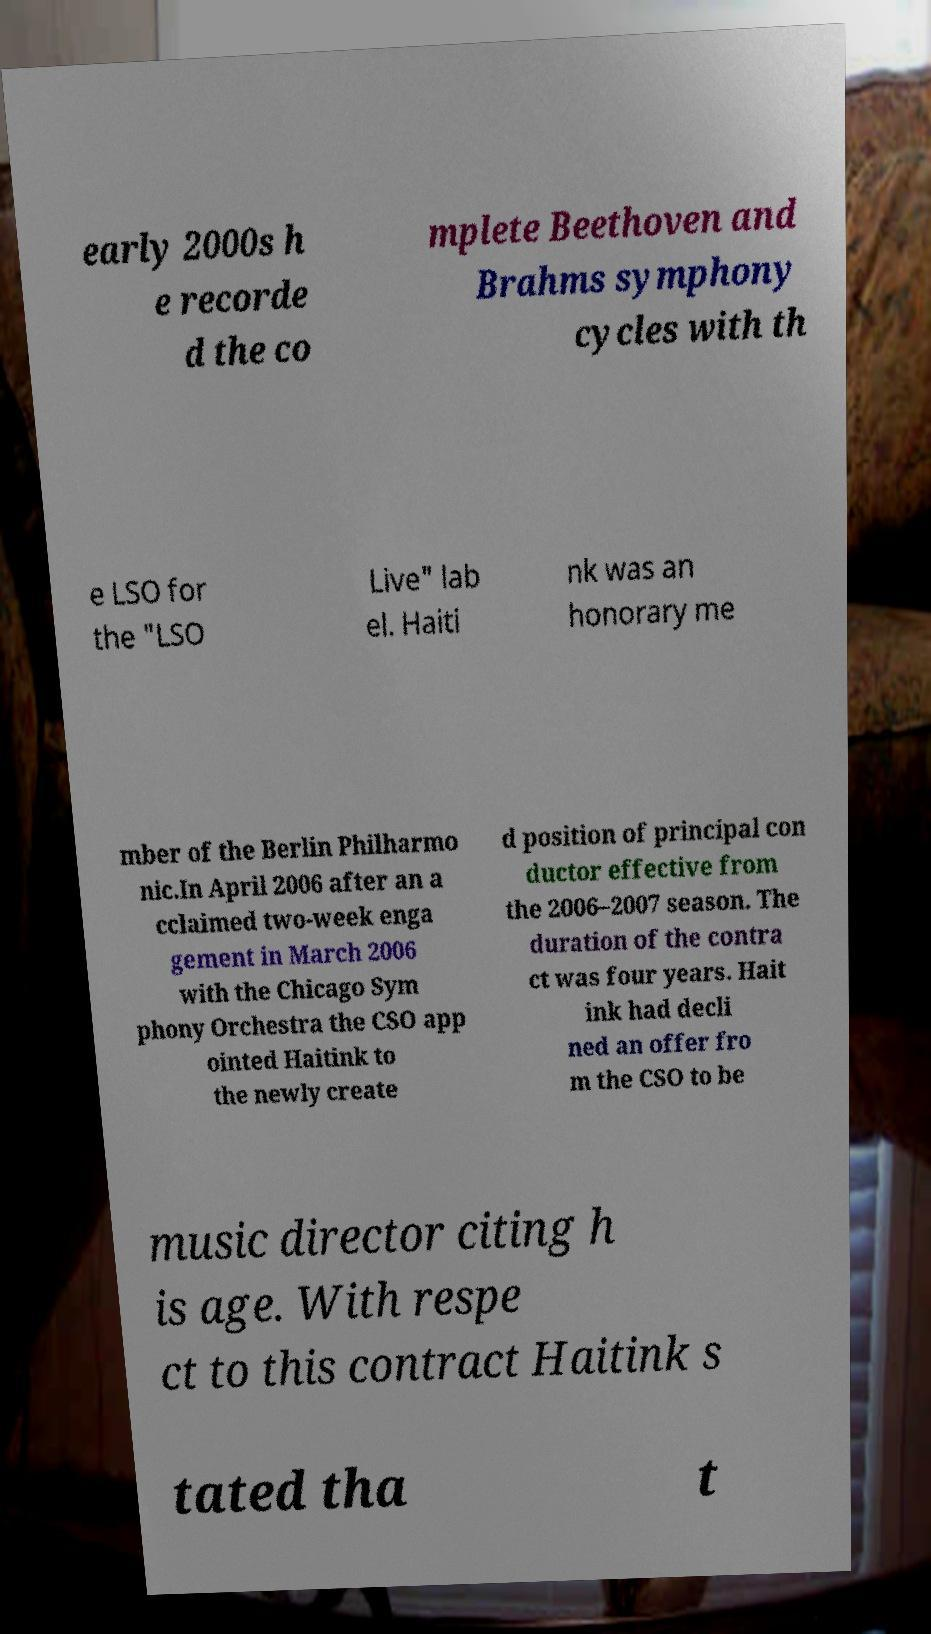Can you read and provide the text displayed in the image?This photo seems to have some interesting text. Can you extract and type it out for me? early 2000s h e recorde d the co mplete Beethoven and Brahms symphony cycles with th e LSO for the "LSO Live" lab el. Haiti nk was an honorary me mber of the Berlin Philharmo nic.In April 2006 after an a cclaimed two-week enga gement in March 2006 with the Chicago Sym phony Orchestra the CSO app ointed Haitink to the newly create d position of principal con ductor effective from the 2006–2007 season. The duration of the contra ct was four years. Hait ink had decli ned an offer fro m the CSO to be music director citing h is age. With respe ct to this contract Haitink s tated tha t 